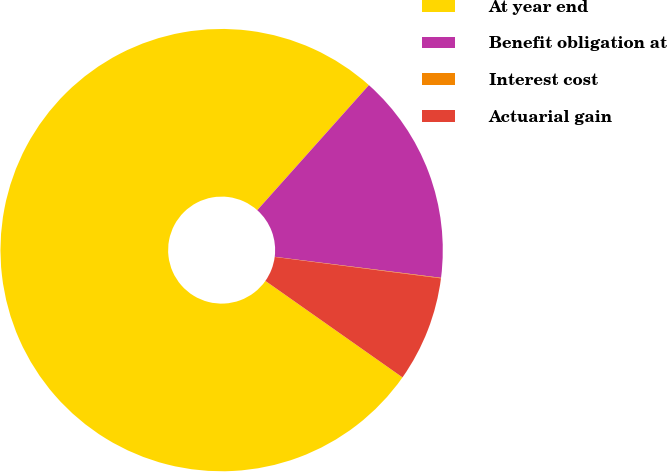<chart> <loc_0><loc_0><loc_500><loc_500><pie_chart><fcel>At year end<fcel>Benefit obligation at<fcel>Interest cost<fcel>Actuarial gain<nl><fcel>76.84%<fcel>15.4%<fcel>0.04%<fcel>7.72%<nl></chart> 